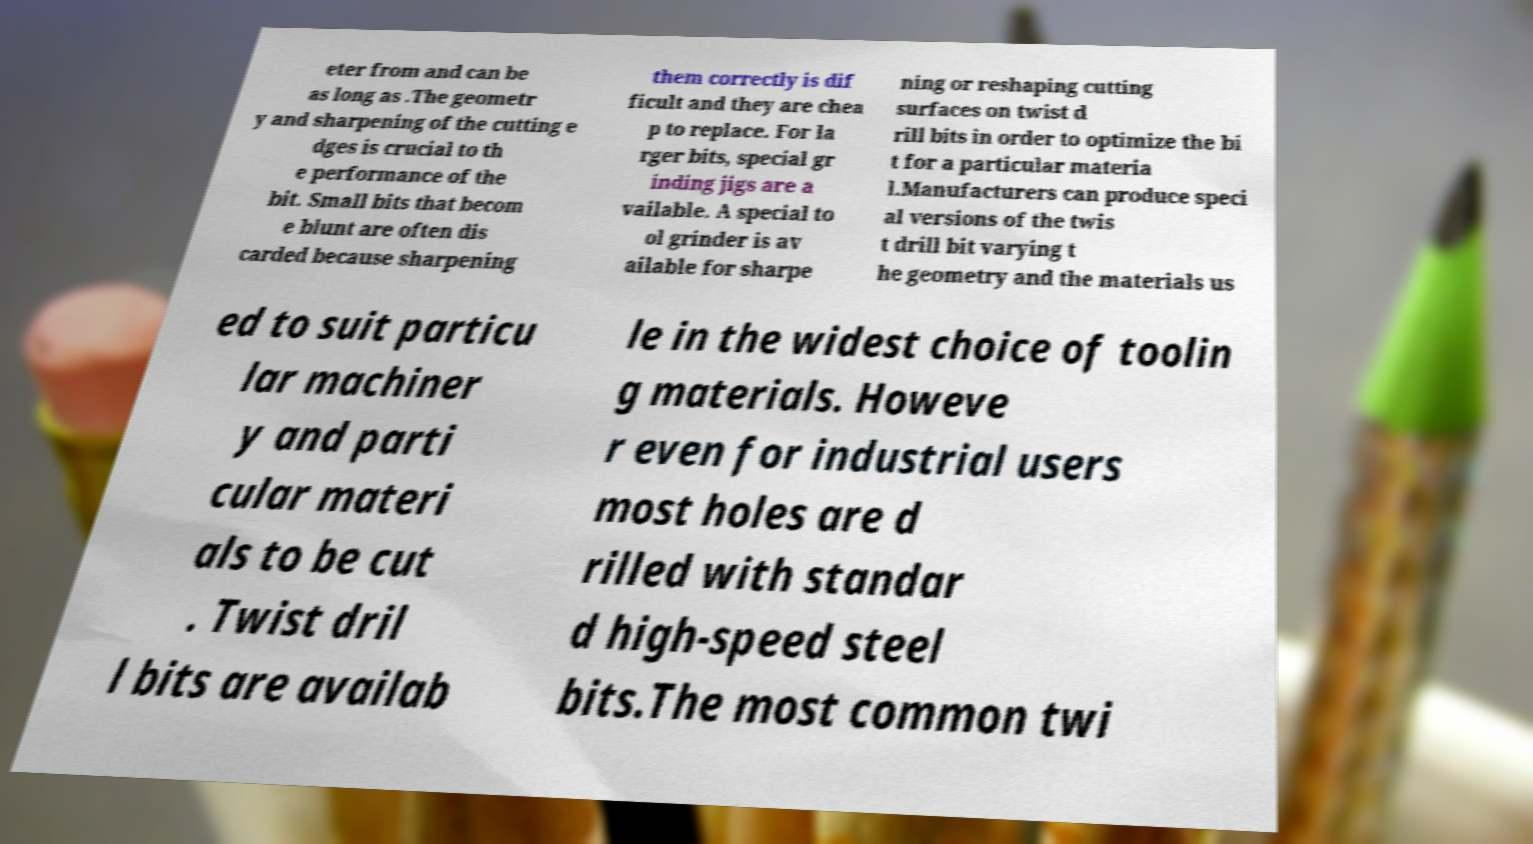Please read and relay the text visible in this image. What does it say? eter from and can be as long as .The geometr y and sharpening of the cutting e dges is crucial to th e performance of the bit. Small bits that becom e blunt are often dis carded because sharpening them correctly is dif ficult and they are chea p to replace. For la rger bits, special gr inding jigs are a vailable. A special to ol grinder is av ailable for sharpe ning or reshaping cutting surfaces on twist d rill bits in order to optimize the bi t for a particular materia l.Manufacturers can produce speci al versions of the twis t drill bit varying t he geometry and the materials us ed to suit particu lar machiner y and parti cular materi als to be cut . Twist dril l bits are availab le in the widest choice of toolin g materials. Howeve r even for industrial users most holes are d rilled with standar d high-speed steel bits.The most common twi 